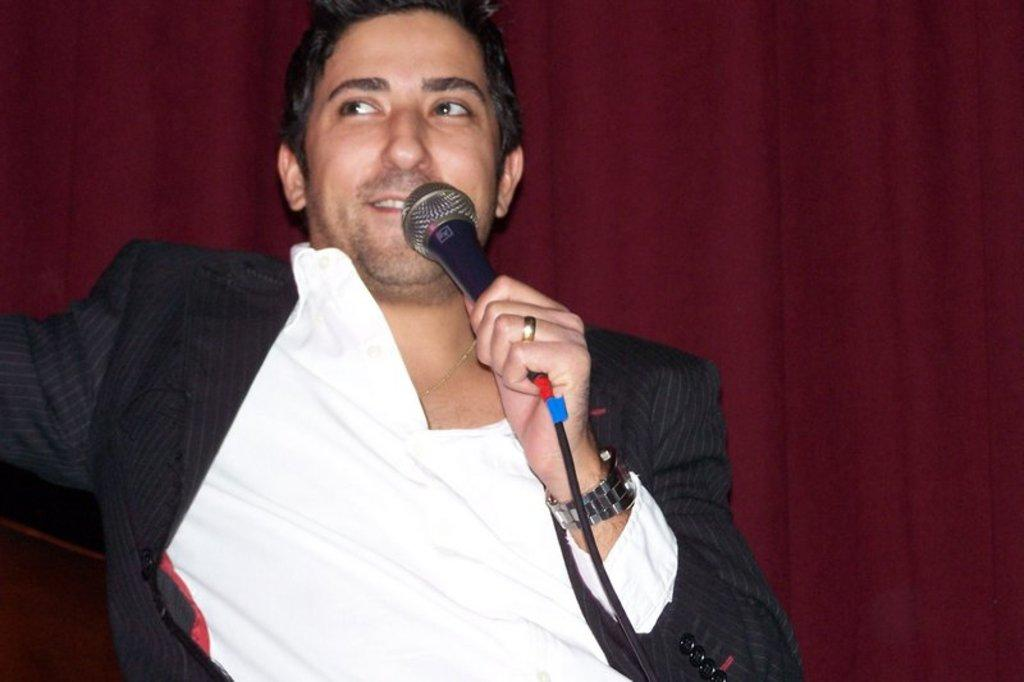Who is present in the image? There is a man in the image. What is the man wearing? The man is wearing a black blazer. What is the man holding in the image? The man is holding a microphone. What can be seen in the background of the image? There is a curtain in the background of the image. What type of cord is the boy using to gain knowledge in the image? There is no boy or cord present in the image, and no mention of gaining knowledge. 